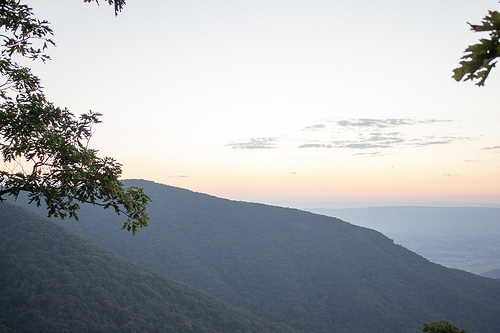<image>
Can you confirm if the mountain is behind the mountain? Yes. From this viewpoint, the mountain is positioned behind the mountain, with the mountain partially or fully occluding the mountain. Where is the tree in relation to the hill? Is it behind the hill? No. The tree is not behind the hill. From this viewpoint, the tree appears to be positioned elsewhere in the scene. 